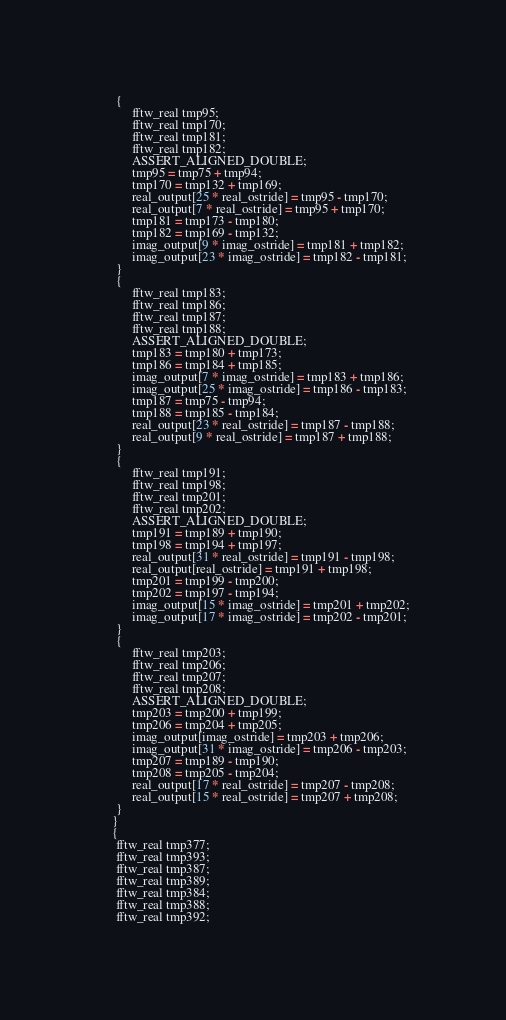Convert code to text. <code><loc_0><loc_0><loc_500><loc_500><_C_>	  {
	       fftw_real tmp95;
	       fftw_real tmp170;
	       fftw_real tmp181;
	       fftw_real tmp182;
	       ASSERT_ALIGNED_DOUBLE;
	       tmp95 = tmp75 + tmp94;
	       tmp170 = tmp132 + tmp169;
	       real_output[25 * real_ostride] = tmp95 - tmp170;
	       real_output[7 * real_ostride] = tmp95 + tmp170;
	       tmp181 = tmp173 - tmp180;
	       tmp182 = tmp169 - tmp132;
	       imag_output[9 * imag_ostride] = tmp181 + tmp182;
	       imag_output[23 * imag_ostride] = tmp182 - tmp181;
	  }
	  {
	       fftw_real tmp183;
	       fftw_real tmp186;
	       fftw_real tmp187;
	       fftw_real tmp188;
	       ASSERT_ALIGNED_DOUBLE;
	       tmp183 = tmp180 + tmp173;
	       tmp186 = tmp184 + tmp185;
	       imag_output[7 * imag_ostride] = tmp183 + tmp186;
	       imag_output[25 * imag_ostride] = tmp186 - tmp183;
	       tmp187 = tmp75 - tmp94;
	       tmp188 = tmp185 - tmp184;
	       real_output[23 * real_ostride] = tmp187 - tmp188;
	       real_output[9 * real_ostride] = tmp187 + tmp188;
	  }
	  {
	       fftw_real tmp191;
	       fftw_real tmp198;
	       fftw_real tmp201;
	       fftw_real tmp202;
	       ASSERT_ALIGNED_DOUBLE;
	       tmp191 = tmp189 + tmp190;
	       tmp198 = tmp194 + tmp197;
	       real_output[31 * real_ostride] = tmp191 - tmp198;
	       real_output[real_ostride] = tmp191 + tmp198;
	       tmp201 = tmp199 - tmp200;
	       tmp202 = tmp197 - tmp194;
	       imag_output[15 * imag_ostride] = tmp201 + tmp202;
	       imag_output[17 * imag_ostride] = tmp202 - tmp201;
	  }
	  {
	       fftw_real tmp203;
	       fftw_real tmp206;
	       fftw_real tmp207;
	       fftw_real tmp208;
	       ASSERT_ALIGNED_DOUBLE;
	       tmp203 = tmp200 + tmp199;
	       tmp206 = tmp204 + tmp205;
	       imag_output[imag_ostride] = tmp203 + tmp206;
	       imag_output[31 * imag_ostride] = tmp206 - tmp203;
	       tmp207 = tmp189 - tmp190;
	       tmp208 = tmp205 - tmp204;
	       real_output[17 * real_ostride] = tmp207 - tmp208;
	       real_output[15 * real_ostride] = tmp207 + tmp208;
	  }
     }
     {
	  fftw_real tmp377;
	  fftw_real tmp393;
	  fftw_real tmp387;
	  fftw_real tmp389;
	  fftw_real tmp384;
	  fftw_real tmp388;
	  fftw_real tmp392;</code> 